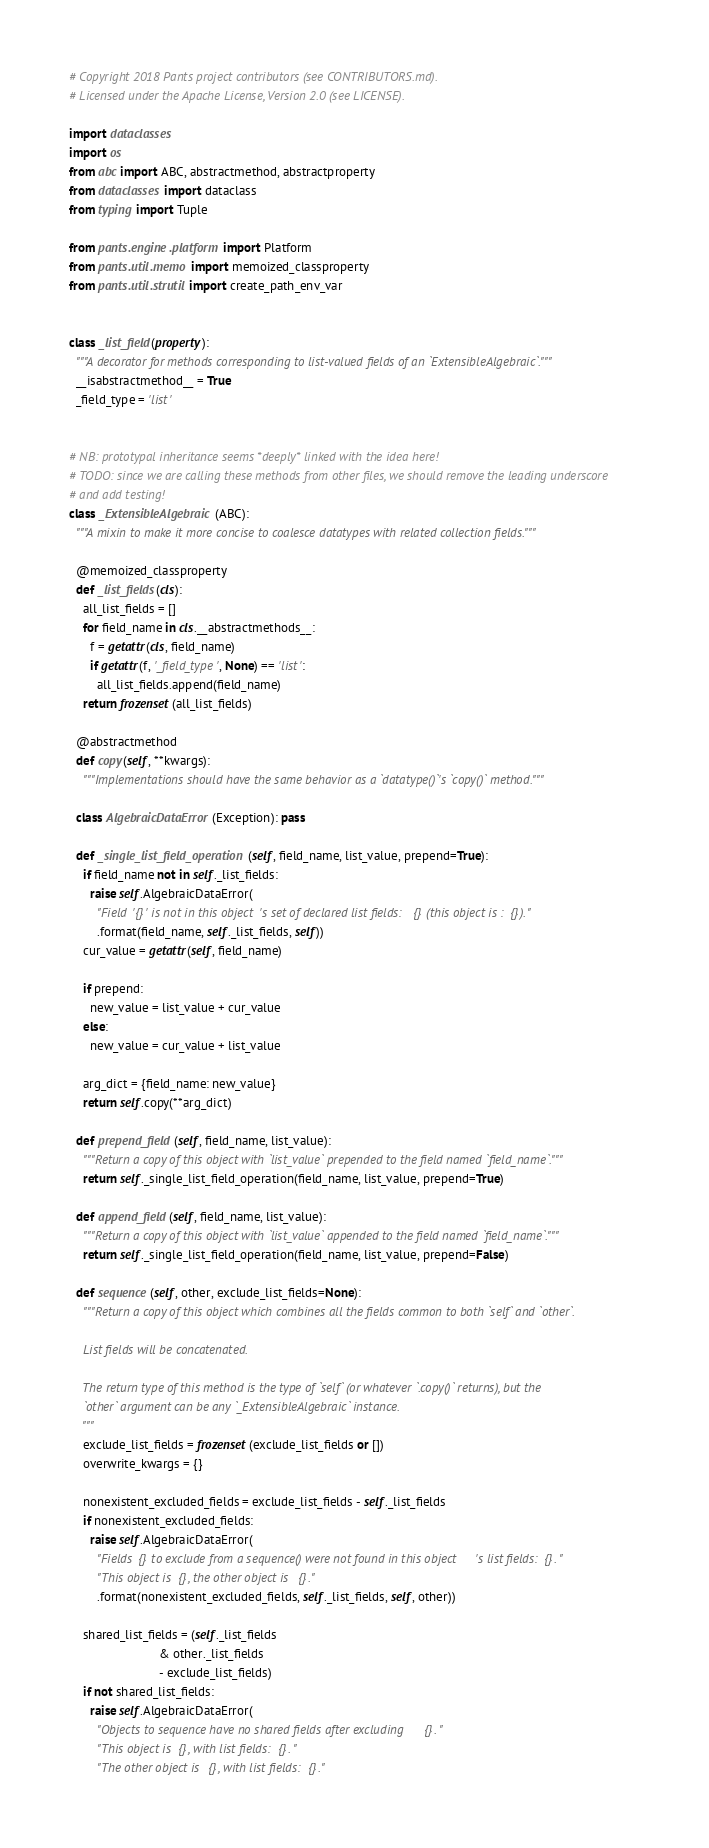<code> <loc_0><loc_0><loc_500><loc_500><_Python_># Copyright 2018 Pants project contributors (see CONTRIBUTORS.md).
# Licensed under the Apache License, Version 2.0 (see LICENSE).

import dataclasses
import os
from abc import ABC, abstractmethod, abstractproperty
from dataclasses import dataclass
from typing import Tuple

from pants.engine.platform import Platform
from pants.util.memo import memoized_classproperty
from pants.util.strutil import create_path_env_var


class _list_field(property):
  """A decorator for methods corresponding to list-valued fields of an `ExtensibleAlgebraic`."""
  __isabstractmethod__ = True
  _field_type = 'list'


# NB: prototypal inheritance seems *deeply* linked with the idea here!
# TODO: since we are calling these methods from other files, we should remove the leading underscore
# and add testing!
class _ExtensibleAlgebraic(ABC):
  """A mixin to make it more concise to coalesce datatypes with related collection fields."""

  @memoized_classproperty
  def _list_fields(cls):
    all_list_fields = []
    for field_name in cls.__abstractmethods__:
      f = getattr(cls, field_name)
      if getattr(f, '_field_type', None) == 'list':
        all_list_fields.append(field_name)
    return frozenset(all_list_fields)

  @abstractmethod
  def copy(self, **kwargs):
    """Implementations should have the same behavior as a `datatype()`'s `copy()` method."""

  class AlgebraicDataError(Exception): pass

  def _single_list_field_operation(self, field_name, list_value, prepend=True):
    if field_name not in self._list_fields:
      raise self.AlgebraicDataError(
        "Field '{}' is not in this object's set of declared list fields: {} (this object is : {})."
        .format(field_name, self._list_fields, self))
    cur_value = getattr(self, field_name)

    if prepend:
      new_value = list_value + cur_value
    else:
      new_value = cur_value + list_value

    arg_dict = {field_name: new_value}
    return self.copy(**arg_dict)

  def prepend_field(self, field_name, list_value):
    """Return a copy of this object with `list_value` prepended to the field named `field_name`."""
    return self._single_list_field_operation(field_name, list_value, prepend=True)

  def append_field(self, field_name, list_value):
    """Return a copy of this object with `list_value` appended to the field named `field_name`."""
    return self._single_list_field_operation(field_name, list_value, prepend=False)

  def sequence(self, other, exclude_list_fields=None):
    """Return a copy of this object which combines all the fields common to both `self` and `other`.

    List fields will be concatenated.

    The return type of this method is the type of `self` (or whatever `.copy()` returns), but the
    `other` argument can be any `_ExtensibleAlgebraic` instance.
    """
    exclude_list_fields = frozenset(exclude_list_fields or [])
    overwrite_kwargs = {}

    nonexistent_excluded_fields = exclude_list_fields - self._list_fields
    if nonexistent_excluded_fields:
      raise self.AlgebraicDataError(
        "Fields {} to exclude from a sequence() were not found in this object's list fields: {}. "
        "This object is {}, the other object is {}."
        .format(nonexistent_excluded_fields, self._list_fields, self, other))

    shared_list_fields = (self._list_fields
                          & other._list_fields
                          - exclude_list_fields)
    if not shared_list_fields:
      raise self.AlgebraicDataError(
        "Objects to sequence have no shared fields after excluding {}. "
        "This object is {}, with list fields: {}. "
        "The other object is {}, with list fields: {}."</code> 